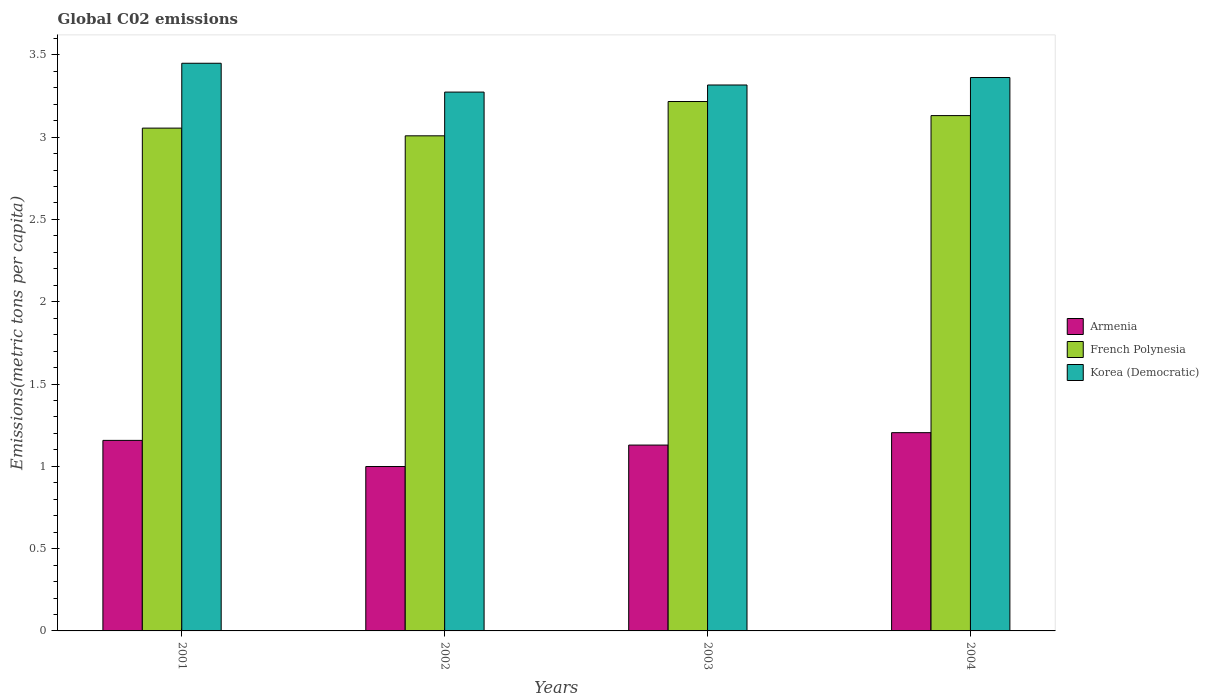In how many cases, is the number of bars for a given year not equal to the number of legend labels?
Keep it short and to the point. 0. What is the amount of CO2 emitted in in French Polynesia in 2003?
Provide a succinct answer. 3.22. Across all years, what is the maximum amount of CO2 emitted in in Armenia?
Offer a terse response. 1.2. Across all years, what is the minimum amount of CO2 emitted in in Armenia?
Your response must be concise. 1. What is the total amount of CO2 emitted in in Korea (Democratic) in the graph?
Your answer should be compact. 13.4. What is the difference between the amount of CO2 emitted in in Korea (Democratic) in 2002 and that in 2004?
Offer a terse response. -0.09. What is the difference between the amount of CO2 emitted in in French Polynesia in 2002 and the amount of CO2 emitted in in Korea (Democratic) in 2004?
Make the answer very short. -0.35. What is the average amount of CO2 emitted in in French Polynesia per year?
Your answer should be very brief. 3.1. In the year 2002, what is the difference between the amount of CO2 emitted in in Korea (Democratic) and amount of CO2 emitted in in French Polynesia?
Provide a succinct answer. 0.27. What is the ratio of the amount of CO2 emitted in in Armenia in 2002 to that in 2004?
Provide a short and direct response. 0.83. Is the amount of CO2 emitted in in Korea (Democratic) in 2002 less than that in 2004?
Your response must be concise. Yes. Is the difference between the amount of CO2 emitted in in Korea (Democratic) in 2003 and 2004 greater than the difference between the amount of CO2 emitted in in French Polynesia in 2003 and 2004?
Provide a succinct answer. No. What is the difference between the highest and the second highest amount of CO2 emitted in in Armenia?
Give a very brief answer. 0.05. What is the difference between the highest and the lowest amount of CO2 emitted in in Korea (Democratic)?
Offer a terse response. 0.18. In how many years, is the amount of CO2 emitted in in Korea (Democratic) greater than the average amount of CO2 emitted in in Korea (Democratic) taken over all years?
Your response must be concise. 2. Is the sum of the amount of CO2 emitted in in Armenia in 2001 and 2004 greater than the maximum amount of CO2 emitted in in Korea (Democratic) across all years?
Provide a short and direct response. No. What does the 2nd bar from the left in 2003 represents?
Keep it short and to the point. French Polynesia. What does the 2nd bar from the right in 2001 represents?
Give a very brief answer. French Polynesia. How many bars are there?
Provide a succinct answer. 12. Are all the bars in the graph horizontal?
Your answer should be very brief. No. How many years are there in the graph?
Offer a terse response. 4. What is the difference between two consecutive major ticks on the Y-axis?
Ensure brevity in your answer.  0.5. Where does the legend appear in the graph?
Your response must be concise. Center right. How many legend labels are there?
Provide a succinct answer. 3. How are the legend labels stacked?
Offer a terse response. Vertical. What is the title of the graph?
Provide a short and direct response. Global C02 emissions. Does "Europe(developing only)" appear as one of the legend labels in the graph?
Keep it short and to the point. No. What is the label or title of the Y-axis?
Your answer should be very brief. Emissions(metric tons per capita). What is the Emissions(metric tons per capita) in Armenia in 2001?
Your answer should be very brief. 1.16. What is the Emissions(metric tons per capita) in French Polynesia in 2001?
Your answer should be very brief. 3.05. What is the Emissions(metric tons per capita) in Korea (Democratic) in 2001?
Your response must be concise. 3.45. What is the Emissions(metric tons per capita) in Armenia in 2002?
Your answer should be very brief. 1. What is the Emissions(metric tons per capita) of French Polynesia in 2002?
Your response must be concise. 3.01. What is the Emissions(metric tons per capita) in Korea (Democratic) in 2002?
Keep it short and to the point. 3.27. What is the Emissions(metric tons per capita) in Armenia in 2003?
Provide a short and direct response. 1.13. What is the Emissions(metric tons per capita) of French Polynesia in 2003?
Provide a short and direct response. 3.22. What is the Emissions(metric tons per capita) of Korea (Democratic) in 2003?
Keep it short and to the point. 3.32. What is the Emissions(metric tons per capita) of Armenia in 2004?
Provide a succinct answer. 1.2. What is the Emissions(metric tons per capita) of French Polynesia in 2004?
Offer a terse response. 3.13. What is the Emissions(metric tons per capita) in Korea (Democratic) in 2004?
Ensure brevity in your answer.  3.36. Across all years, what is the maximum Emissions(metric tons per capita) in Armenia?
Provide a succinct answer. 1.2. Across all years, what is the maximum Emissions(metric tons per capita) of French Polynesia?
Offer a terse response. 3.22. Across all years, what is the maximum Emissions(metric tons per capita) in Korea (Democratic)?
Ensure brevity in your answer.  3.45. Across all years, what is the minimum Emissions(metric tons per capita) in Armenia?
Your answer should be compact. 1. Across all years, what is the minimum Emissions(metric tons per capita) in French Polynesia?
Provide a succinct answer. 3.01. Across all years, what is the minimum Emissions(metric tons per capita) of Korea (Democratic)?
Your answer should be compact. 3.27. What is the total Emissions(metric tons per capita) in Armenia in the graph?
Give a very brief answer. 4.49. What is the total Emissions(metric tons per capita) in French Polynesia in the graph?
Your answer should be compact. 12.41. What is the total Emissions(metric tons per capita) in Korea (Democratic) in the graph?
Ensure brevity in your answer.  13.4. What is the difference between the Emissions(metric tons per capita) of Armenia in 2001 and that in 2002?
Keep it short and to the point. 0.16. What is the difference between the Emissions(metric tons per capita) of French Polynesia in 2001 and that in 2002?
Make the answer very short. 0.05. What is the difference between the Emissions(metric tons per capita) in Korea (Democratic) in 2001 and that in 2002?
Ensure brevity in your answer.  0.18. What is the difference between the Emissions(metric tons per capita) of Armenia in 2001 and that in 2003?
Provide a succinct answer. 0.03. What is the difference between the Emissions(metric tons per capita) of French Polynesia in 2001 and that in 2003?
Your answer should be very brief. -0.16. What is the difference between the Emissions(metric tons per capita) of Korea (Democratic) in 2001 and that in 2003?
Your response must be concise. 0.13. What is the difference between the Emissions(metric tons per capita) of Armenia in 2001 and that in 2004?
Your answer should be very brief. -0.05. What is the difference between the Emissions(metric tons per capita) in French Polynesia in 2001 and that in 2004?
Offer a very short reply. -0.08. What is the difference between the Emissions(metric tons per capita) of Korea (Democratic) in 2001 and that in 2004?
Your answer should be very brief. 0.09. What is the difference between the Emissions(metric tons per capita) in Armenia in 2002 and that in 2003?
Keep it short and to the point. -0.13. What is the difference between the Emissions(metric tons per capita) of French Polynesia in 2002 and that in 2003?
Ensure brevity in your answer.  -0.21. What is the difference between the Emissions(metric tons per capita) of Korea (Democratic) in 2002 and that in 2003?
Your response must be concise. -0.04. What is the difference between the Emissions(metric tons per capita) in Armenia in 2002 and that in 2004?
Offer a very short reply. -0.21. What is the difference between the Emissions(metric tons per capita) of French Polynesia in 2002 and that in 2004?
Your answer should be compact. -0.12. What is the difference between the Emissions(metric tons per capita) in Korea (Democratic) in 2002 and that in 2004?
Offer a very short reply. -0.09. What is the difference between the Emissions(metric tons per capita) of Armenia in 2003 and that in 2004?
Your answer should be very brief. -0.08. What is the difference between the Emissions(metric tons per capita) in French Polynesia in 2003 and that in 2004?
Your answer should be compact. 0.09. What is the difference between the Emissions(metric tons per capita) of Korea (Democratic) in 2003 and that in 2004?
Your answer should be compact. -0.05. What is the difference between the Emissions(metric tons per capita) of Armenia in 2001 and the Emissions(metric tons per capita) of French Polynesia in 2002?
Your answer should be very brief. -1.85. What is the difference between the Emissions(metric tons per capita) of Armenia in 2001 and the Emissions(metric tons per capita) of Korea (Democratic) in 2002?
Your answer should be very brief. -2.12. What is the difference between the Emissions(metric tons per capita) of French Polynesia in 2001 and the Emissions(metric tons per capita) of Korea (Democratic) in 2002?
Your response must be concise. -0.22. What is the difference between the Emissions(metric tons per capita) of Armenia in 2001 and the Emissions(metric tons per capita) of French Polynesia in 2003?
Give a very brief answer. -2.06. What is the difference between the Emissions(metric tons per capita) of Armenia in 2001 and the Emissions(metric tons per capita) of Korea (Democratic) in 2003?
Provide a short and direct response. -2.16. What is the difference between the Emissions(metric tons per capita) of French Polynesia in 2001 and the Emissions(metric tons per capita) of Korea (Democratic) in 2003?
Your answer should be very brief. -0.26. What is the difference between the Emissions(metric tons per capita) in Armenia in 2001 and the Emissions(metric tons per capita) in French Polynesia in 2004?
Offer a very short reply. -1.97. What is the difference between the Emissions(metric tons per capita) in Armenia in 2001 and the Emissions(metric tons per capita) in Korea (Democratic) in 2004?
Keep it short and to the point. -2.2. What is the difference between the Emissions(metric tons per capita) in French Polynesia in 2001 and the Emissions(metric tons per capita) in Korea (Democratic) in 2004?
Keep it short and to the point. -0.31. What is the difference between the Emissions(metric tons per capita) of Armenia in 2002 and the Emissions(metric tons per capita) of French Polynesia in 2003?
Ensure brevity in your answer.  -2.22. What is the difference between the Emissions(metric tons per capita) in Armenia in 2002 and the Emissions(metric tons per capita) in Korea (Democratic) in 2003?
Keep it short and to the point. -2.32. What is the difference between the Emissions(metric tons per capita) of French Polynesia in 2002 and the Emissions(metric tons per capita) of Korea (Democratic) in 2003?
Your answer should be compact. -0.31. What is the difference between the Emissions(metric tons per capita) of Armenia in 2002 and the Emissions(metric tons per capita) of French Polynesia in 2004?
Give a very brief answer. -2.13. What is the difference between the Emissions(metric tons per capita) in Armenia in 2002 and the Emissions(metric tons per capita) in Korea (Democratic) in 2004?
Offer a very short reply. -2.36. What is the difference between the Emissions(metric tons per capita) in French Polynesia in 2002 and the Emissions(metric tons per capita) in Korea (Democratic) in 2004?
Your answer should be compact. -0.35. What is the difference between the Emissions(metric tons per capita) in Armenia in 2003 and the Emissions(metric tons per capita) in French Polynesia in 2004?
Offer a terse response. -2. What is the difference between the Emissions(metric tons per capita) of Armenia in 2003 and the Emissions(metric tons per capita) of Korea (Democratic) in 2004?
Make the answer very short. -2.23. What is the difference between the Emissions(metric tons per capita) in French Polynesia in 2003 and the Emissions(metric tons per capita) in Korea (Democratic) in 2004?
Your answer should be very brief. -0.15. What is the average Emissions(metric tons per capita) in Armenia per year?
Ensure brevity in your answer.  1.12. What is the average Emissions(metric tons per capita) of French Polynesia per year?
Your answer should be very brief. 3.1. What is the average Emissions(metric tons per capita) in Korea (Democratic) per year?
Keep it short and to the point. 3.35. In the year 2001, what is the difference between the Emissions(metric tons per capita) in Armenia and Emissions(metric tons per capita) in French Polynesia?
Your answer should be very brief. -1.9. In the year 2001, what is the difference between the Emissions(metric tons per capita) in Armenia and Emissions(metric tons per capita) in Korea (Democratic)?
Provide a short and direct response. -2.29. In the year 2001, what is the difference between the Emissions(metric tons per capita) of French Polynesia and Emissions(metric tons per capita) of Korea (Democratic)?
Your answer should be very brief. -0.39. In the year 2002, what is the difference between the Emissions(metric tons per capita) of Armenia and Emissions(metric tons per capita) of French Polynesia?
Ensure brevity in your answer.  -2.01. In the year 2002, what is the difference between the Emissions(metric tons per capita) of Armenia and Emissions(metric tons per capita) of Korea (Democratic)?
Provide a short and direct response. -2.27. In the year 2002, what is the difference between the Emissions(metric tons per capita) in French Polynesia and Emissions(metric tons per capita) in Korea (Democratic)?
Ensure brevity in your answer.  -0.27. In the year 2003, what is the difference between the Emissions(metric tons per capita) of Armenia and Emissions(metric tons per capita) of French Polynesia?
Offer a very short reply. -2.09. In the year 2003, what is the difference between the Emissions(metric tons per capita) in Armenia and Emissions(metric tons per capita) in Korea (Democratic)?
Provide a succinct answer. -2.19. In the year 2003, what is the difference between the Emissions(metric tons per capita) in French Polynesia and Emissions(metric tons per capita) in Korea (Democratic)?
Offer a very short reply. -0.1. In the year 2004, what is the difference between the Emissions(metric tons per capita) in Armenia and Emissions(metric tons per capita) in French Polynesia?
Provide a short and direct response. -1.93. In the year 2004, what is the difference between the Emissions(metric tons per capita) in Armenia and Emissions(metric tons per capita) in Korea (Democratic)?
Make the answer very short. -2.16. In the year 2004, what is the difference between the Emissions(metric tons per capita) in French Polynesia and Emissions(metric tons per capita) in Korea (Democratic)?
Make the answer very short. -0.23. What is the ratio of the Emissions(metric tons per capita) of Armenia in 2001 to that in 2002?
Provide a succinct answer. 1.16. What is the ratio of the Emissions(metric tons per capita) of French Polynesia in 2001 to that in 2002?
Make the answer very short. 1.02. What is the ratio of the Emissions(metric tons per capita) in Korea (Democratic) in 2001 to that in 2002?
Make the answer very short. 1.05. What is the ratio of the Emissions(metric tons per capita) in Armenia in 2001 to that in 2003?
Offer a terse response. 1.03. What is the ratio of the Emissions(metric tons per capita) in French Polynesia in 2001 to that in 2003?
Ensure brevity in your answer.  0.95. What is the ratio of the Emissions(metric tons per capita) in Korea (Democratic) in 2001 to that in 2003?
Your answer should be compact. 1.04. What is the ratio of the Emissions(metric tons per capita) of French Polynesia in 2001 to that in 2004?
Ensure brevity in your answer.  0.98. What is the ratio of the Emissions(metric tons per capita) of Korea (Democratic) in 2001 to that in 2004?
Make the answer very short. 1.03. What is the ratio of the Emissions(metric tons per capita) in Armenia in 2002 to that in 2003?
Your answer should be very brief. 0.88. What is the ratio of the Emissions(metric tons per capita) in French Polynesia in 2002 to that in 2003?
Your response must be concise. 0.94. What is the ratio of the Emissions(metric tons per capita) in Korea (Democratic) in 2002 to that in 2003?
Keep it short and to the point. 0.99. What is the ratio of the Emissions(metric tons per capita) of Armenia in 2002 to that in 2004?
Your answer should be very brief. 0.83. What is the ratio of the Emissions(metric tons per capita) of French Polynesia in 2002 to that in 2004?
Your answer should be very brief. 0.96. What is the ratio of the Emissions(metric tons per capita) of Korea (Democratic) in 2002 to that in 2004?
Give a very brief answer. 0.97. What is the ratio of the Emissions(metric tons per capita) of Armenia in 2003 to that in 2004?
Offer a very short reply. 0.94. What is the ratio of the Emissions(metric tons per capita) of French Polynesia in 2003 to that in 2004?
Keep it short and to the point. 1.03. What is the ratio of the Emissions(metric tons per capita) in Korea (Democratic) in 2003 to that in 2004?
Your answer should be very brief. 0.99. What is the difference between the highest and the second highest Emissions(metric tons per capita) of Armenia?
Offer a very short reply. 0.05. What is the difference between the highest and the second highest Emissions(metric tons per capita) in French Polynesia?
Make the answer very short. 0.09. What is the difference between the highest and the second highest Emissions(metric tons per capita) of Korea (Democratic)?
Make the answer very short. 0.09. What is the difference between the highest and the lowest Emissions(metric tons per capita) of Armenia?
Ensure brevity in your answer.  0.21. What is the difference between the highest and the lowest Emissions(metric tons per capita) in French Polynesia?
Your response must be concise. 0.21. What is the difference between the highest and the lowest Emissions(metric tons per capita) in Korea (Democratic)?
Make the answer very short. 0.18. 